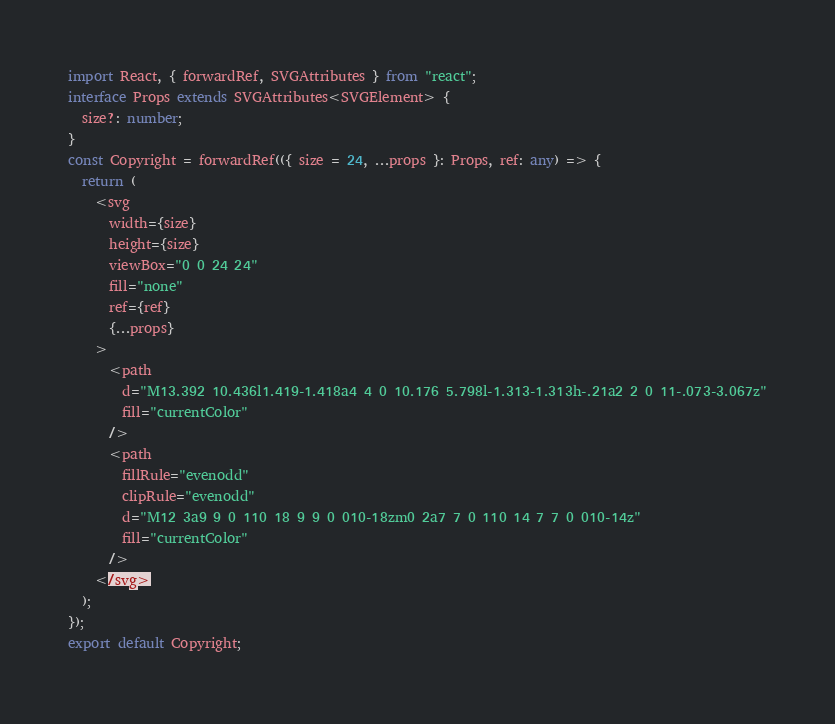<code> <loc_0><loc_0><loc_500><loc_500><_TypeScript_>import React, { forwardRef, SVGAttributes } from "react";
interface Props extends SVGAttributes<SVGElement> {
  size?: number;
}
const Copyright = forwardRef(({ size = 24, ...props }: Props, ref: any) => {
  return (
    <svg
      width={size}
      height={size}
      viewBox="0 0 24 24"
      fill="none"
      ref={ref}
      {...props}
    >
      <path
        d="M13.392 10.436l1.419-1.418a4 4 0 10.176 5.798l-1.313-1.313h-.21a2 2 0 11-.073-3.067z"
        fill="currentColor"
      />
      <path
        fillRule="evenodd"
        clipRule="evenodd"
        d="M12 3a9 9 0 110 18 9 9 0 010-18zm0 2a7 7 0 110 14 7 7 0 010-14z"
        fill="currentColor"
      />
    </svg>
  );
});
export default Copyright;
</code> 